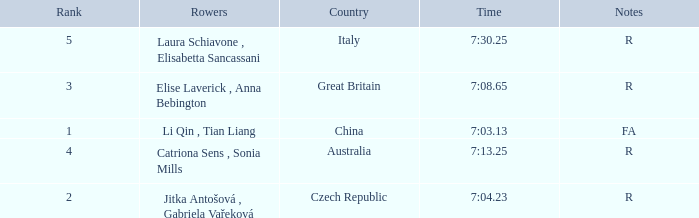What is the Rank of the Rowers with FA as Notes? 1.0. 